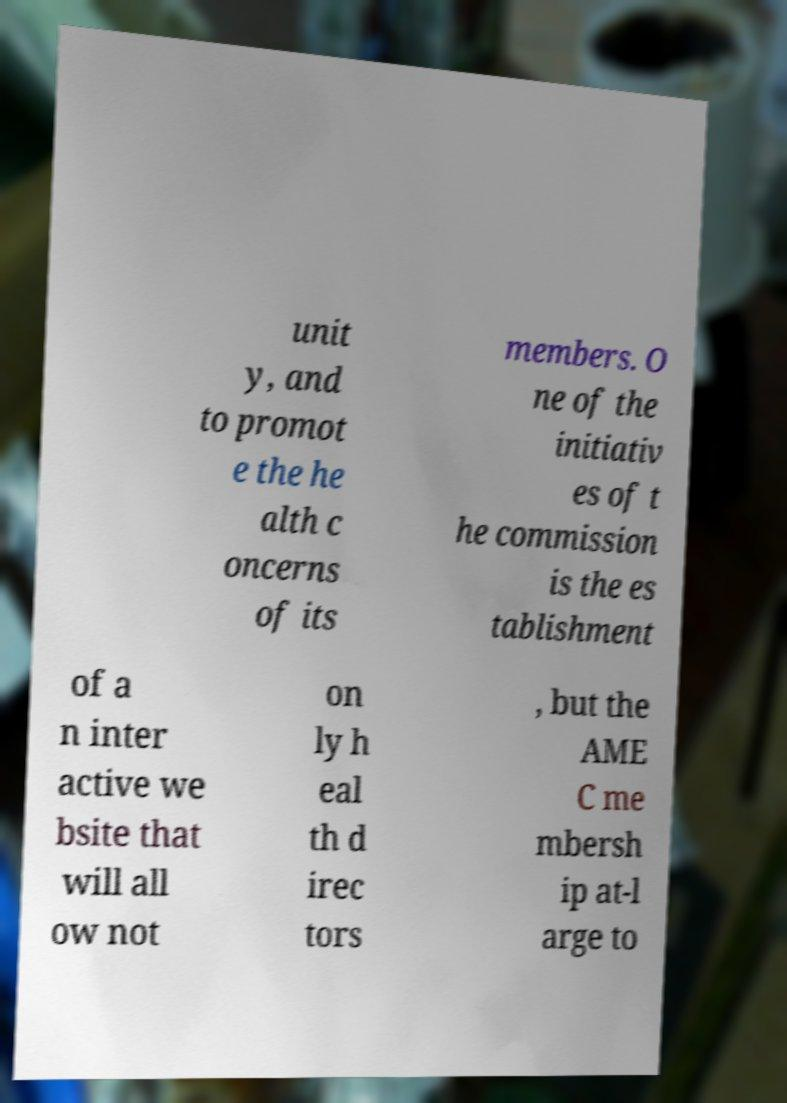For documentation purposes, I need the text within this image transcribed. Could you provide that? unit y, and to promot e the he alth c oncerns of its members. O ne of the initiativ es of t he commission is the es tablishment of a n inter active we bsite that will all ow not on ly h eal th d irec tors , but the AME C me mbersh ip at-l arge to 